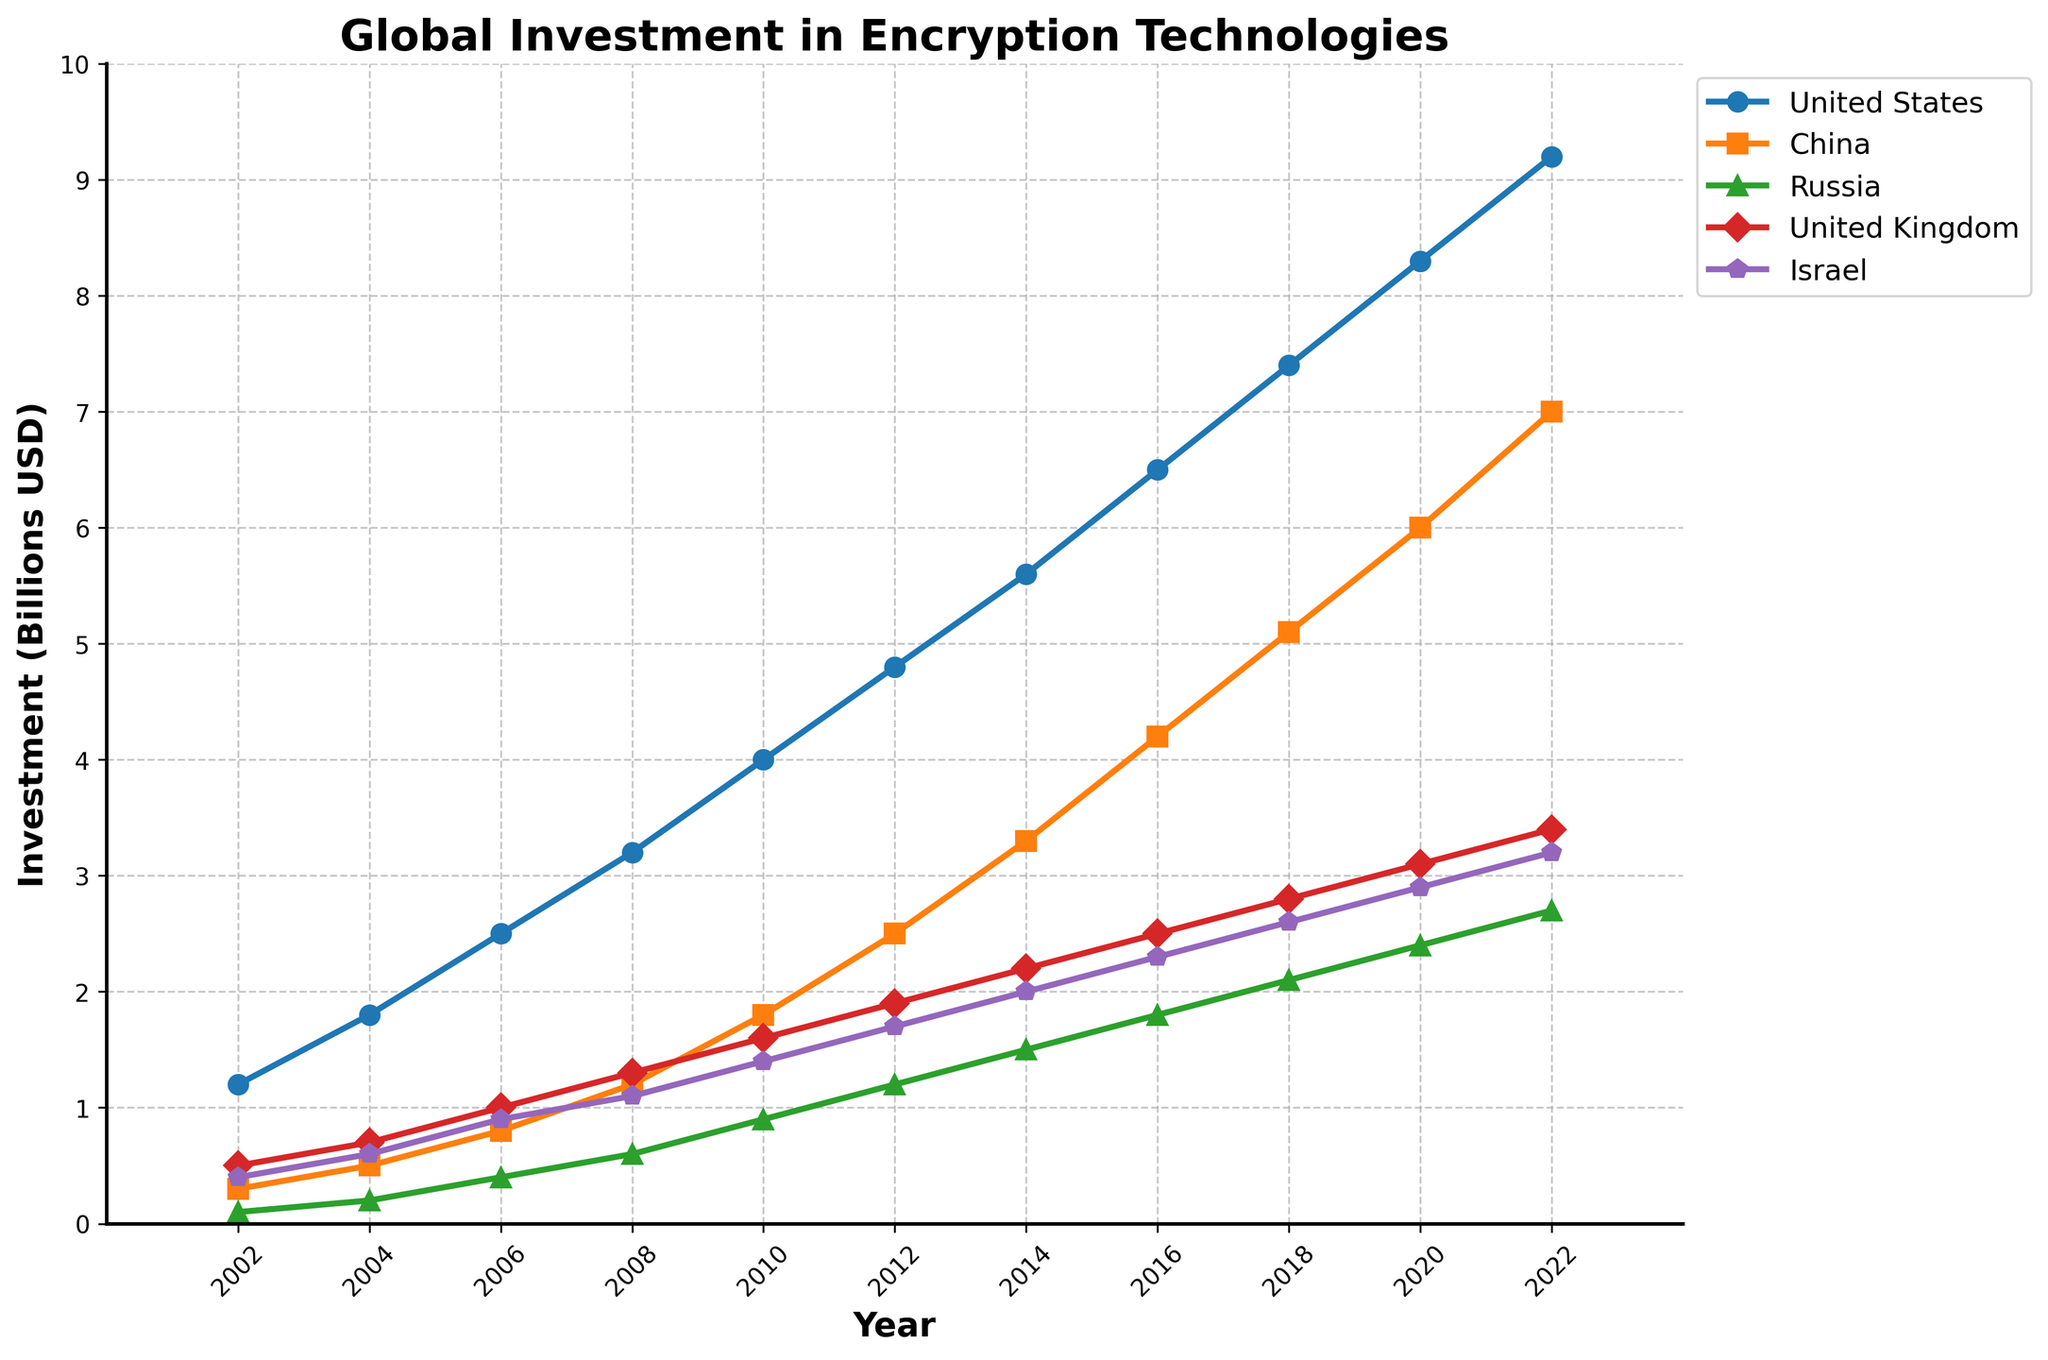what is the overall trend in the United States' investment in encryption technologies from 2002 to 2022? The line graph for the United States shows a steady increase in investment over the 20-year period, starting at 1.2 billion USD in 2002 and rising to 9.2 billion USD in 2022, indicating continuous growth.
Answer: Continuous growth Which country had the second-highest investment in 2022 and what was the investment amount? By looking at the endpoints for 2022 on the line graph, China had the second-highest investment with an amount of 7.0 billion USD after the United States.
Answer: China, 7.0 billion USD How does the investment in encryption technologies by Russia in 2022 compare to its investment in 2002? Russia's investment increased from 0.1 billion USD in 2002 to 2.7 billion USD in 2022. The line graph shows a consistent rise over the years.
Answer: Increased, from 0.1 to 2.7 billion USD What is the range of investment for Israel between 2002 and 2022? Israel's investment starts at 0.4 billion USD in 2002 and increases to 3.2 billion USD in 2022. The range is calculated as 3.2 - 0.4 billion USD.
Answer: 2.8 billion USD Which country showed the most significant rate of increase in investment from 2002 to 2022? Comparing the slopes of the lines, China shows the most significant rate of increase, starting from 0.3 billion USD in 2002 and reaching 7.0 billion USD in 2022, which is a large difference relative to its initial value.
Answer: China In which year did the UK surpass a 2 billion USD investment in encryption technologies for the first time? By examining the UK's line, it surpassed the 2 billion USD mark between 2012 and 2014. In 2014, the investment reaches 2.2 billion USD.
Answer: 2014 What was the average investment of all given countries combined in the year 2020? Sum the investments for 2020: 8.3 (US) + 6.0 (China) + 2.4 (Russia) + 3.1 (UK) + 2.9 (Israel) = 22.7 billion USD, then divide by 5 countries. (22.7 / 5)
Answer: 4.54 billion USD How does the total investment in encryption technologies in 2016 compare to 2006 for all countries combined? Sum investments for each year: 2016 = 6.5 (US) + 4.2 (China) + 1.8 (Russia) + 2.5 (UK) + 2.3 (Israel) = 17.3 billion USD; 2006 = 2.5 (US) + 0.8 (China) + 0.4 (Russia) + 1.0 (UK) + 0.9 (Israel) = 5.6 billion USD; 17.3 - 5.6
Answer: Increased by 11.7 billion USD 